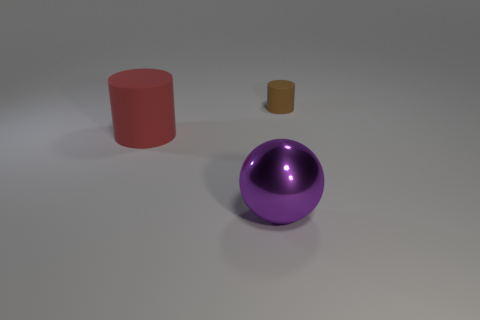What number of rubber cylinders are in front of the cylinder in front of the rubber object that is to the right of the big sphere?
Offer a terse response. 0. Are there fewer tiny rubber things that are in front of the shiny ball than cylinders that are right of the tiny rubber cylinder?
Your answer should be very brief. No. What color is the other small rubber object that is the same shape as the red matte thing?
Offer a terse response. Brown. What size is the purple metal ball?
Your answer should be compact. Large. What number of red rubber cylinders have the same size as the ball?
Your answer should be very brief. 1. Is the big metallic thing the same color as the tiny matte cylinder?
Your answer should be very brief. No. Does the cylinder that is in front of the small brown thing have the same material as the purple ball to the left of the small matte thing?
Make the answer very short. No. Is the number of small yellow things greater than the number of tiny matte objects?
Your response must be concise. No. Is there anything else that has the same color as the sphere?
Offer a very short reply. No. Is the small cylinder made of the same material as the big cylinder?
Make the answer very short. Yes. 